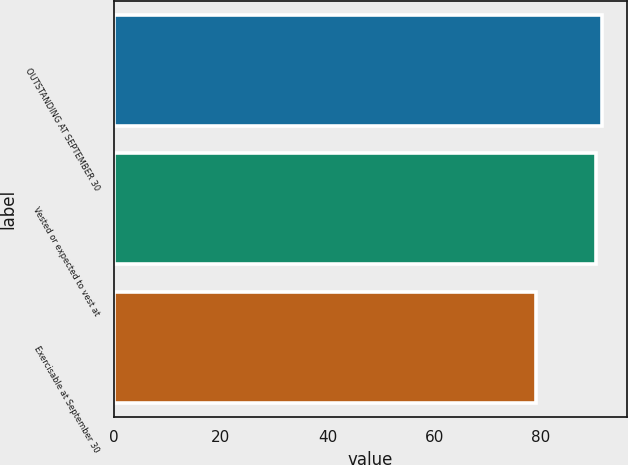Convert chart to OTSL. <chart><loc_0><loc_0><loc_500><loc_500><bar_chart><fcel>OUTSTANDING AT SEPTEMBER 30<fcel>Vested or expected to vest at<fcel>Exercisable at September 30<nl><fcel>91.49<fcel>90.31<fcel>79.15<nl></chart> 